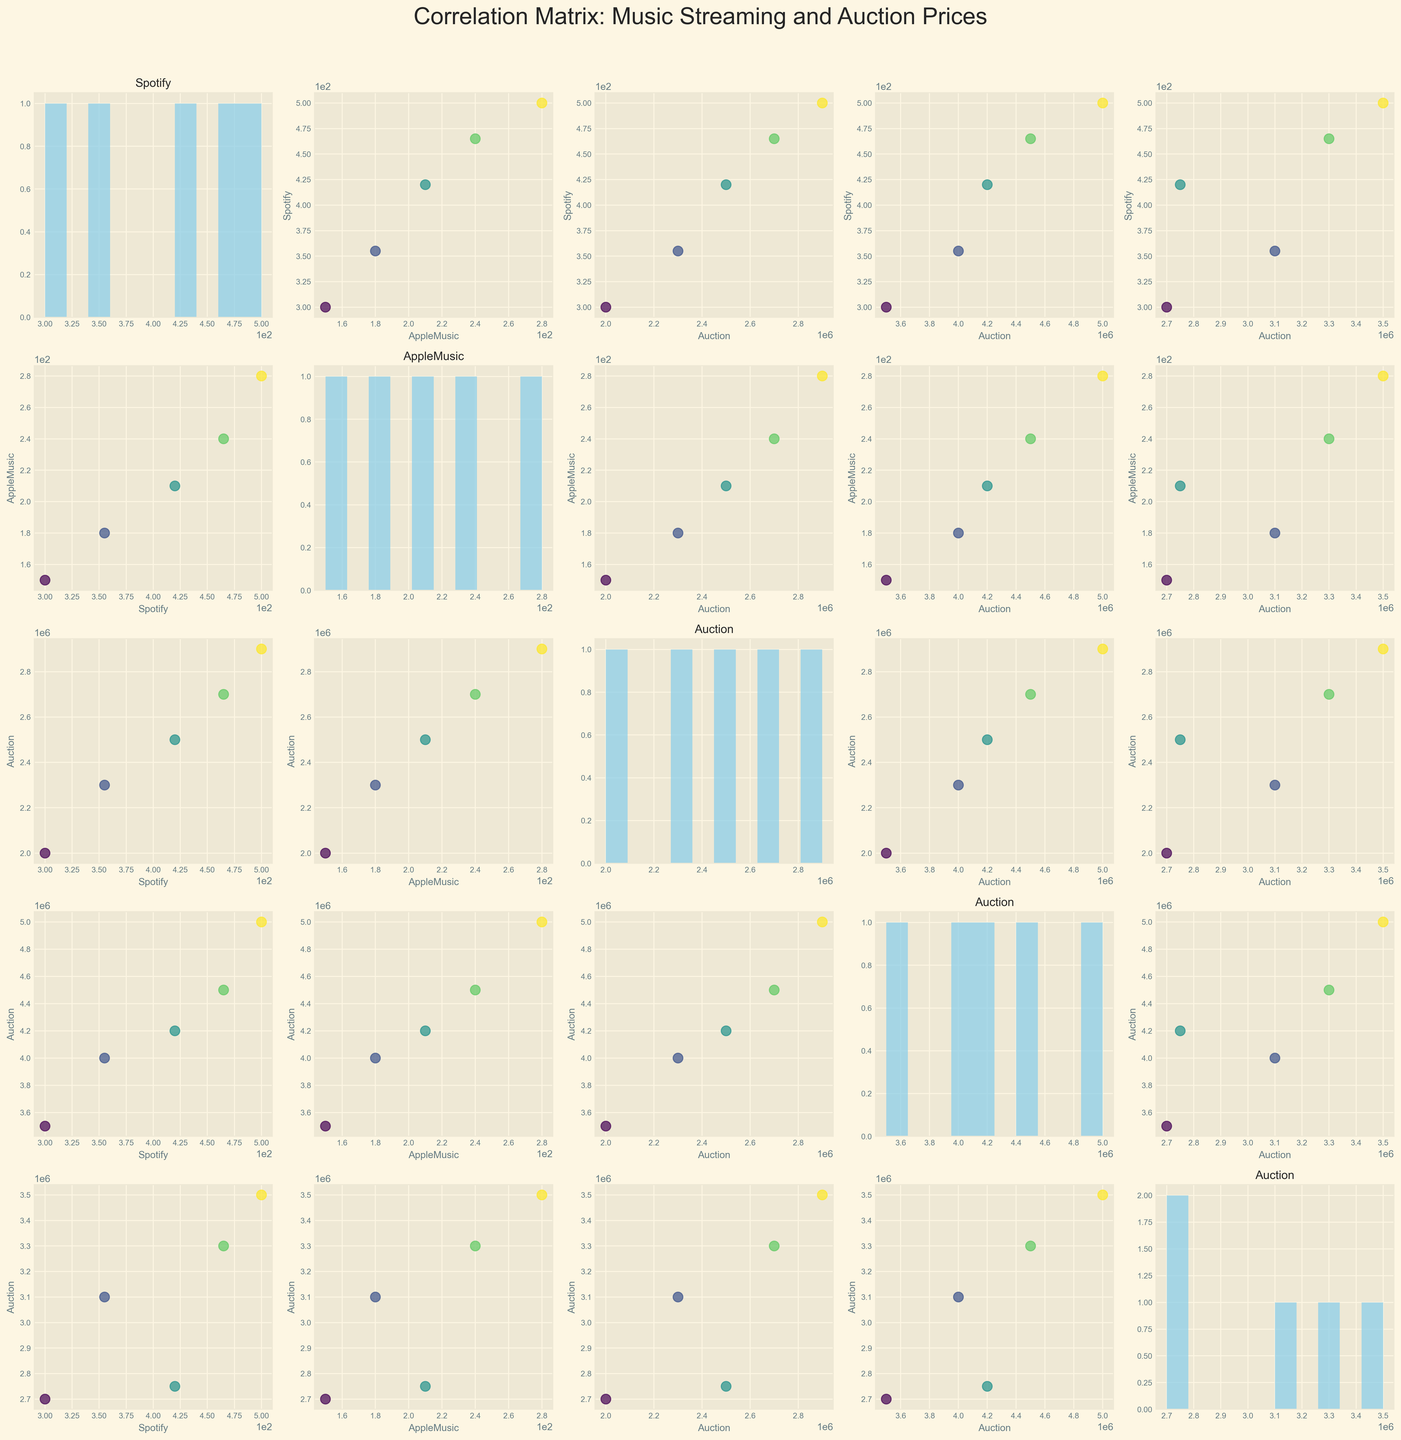How does the auction price for guitars relate to Spotify stream counts over the years? To determine the relationship, observe the scatter plots where the x-axis represents "Spotify_Stream_Counts_Billions" and the y-axis represents "Auction_Price_Guitar_USD". Point colors denote different years, ranging from 2018 to 2022. Typically, the points should show if there's a visual trend, such as an upward or downward trajectory, indicating correlation.
Answer: Generally positive correlation Which has a higher variance, auction prices of pianos or violins? To compare the variance, examine the histograms along the diagonal of the scatter plot matrix for "Auction_Price_Piano_USD" and "Auction_Price_Violin_USD". Variance is suggested by the spread; a wider spread indicates higher variance.
Answer: Pianos Is there a consistent trend between Apple Music stream counts and Spotify stream counts? Locate the scatter plot where the x-axis is "Spotify_Stream_Counts_Billions" and the y-axis is "AppleMusic_Stream_Counts_Billions". Check the plot for any clear linear trends or patterns linking the two axes points over the years.
Answer: Yes, positive trend Do auction prices for guitars tend to increase with the year? To assess this, examine the data points on the histogram for "Auction_Price_Guitar_USD" which also implicitly shows year labels as colors. Older years might show lower placement while recent years show higher.
Answer: Yes Which year had the highest Apple Music stream counts? Observing the histogram associated with "AppleMusic_Stream_Counts_Billions" along the diagonal of the matrix, determine the year by noting the color with the highest count.
Answer: 2022 Are higher auction prices for pianos connected to higher Apple Music stream counts? To check this relationship, look at the scatter plot where "Auction_Price_Piano_USD" is on the y-axis and "AppleMusic_Stream_Counts_Billions" is on the x-axis. Assess if the points exhibit an upward trend, symbolizing a connection.
Answer: Yes Do higher auction prices for violins correlate strongly with any streaming service? Investigate two scatter plots: one where "Auction_Price_Violin_USD" is on the y-axis and "Spotify_Stream_Counts_Billions" is on the x-axis, and another where "Auction_Price_Violin_USD" is on the y-axis and "AppleMusic_Stream_Counts_Billions" is on the x-axis. Check if either plot shows a stronger trend or tighter clustering of data points.
Answer: Slightly more with Apple Music How do guitar auction prices compare to piano auction prices across the years? By examining the scatter plot where "Auction_Price_Guitar_USD" is on the x-axis and "Auction_Price_Piano_USD" is on the y-axis, notice if data points for different years (color-coded) suggest one typically being higher.
Answer: Pianos generally higher Has the top Spotify artist each year had any clear influence on the auction prices of guitars? This requires comparing the scatter plot trends of "Spotify_Stream_Counts_Billions" with "Auction_Price_Guitar_USD" and relating the top artist (implicit in year colors) in each year to any significant shifts in auction prices.
Answer: Influence unclear Which streaming service, Spotify or Apple Music, seems to have a more pronounced effect on the auction prices of iconic guitars? Analyze the correlation strength by comparing scatter plots: first "Auction_Price_Guitar_USD" against "Spotify_Stream_Counts_Billions", and second against "AppleMusic_Stream_Counts_Billions." Look for clearer, more pronounced trends.
Answer: Spotify 